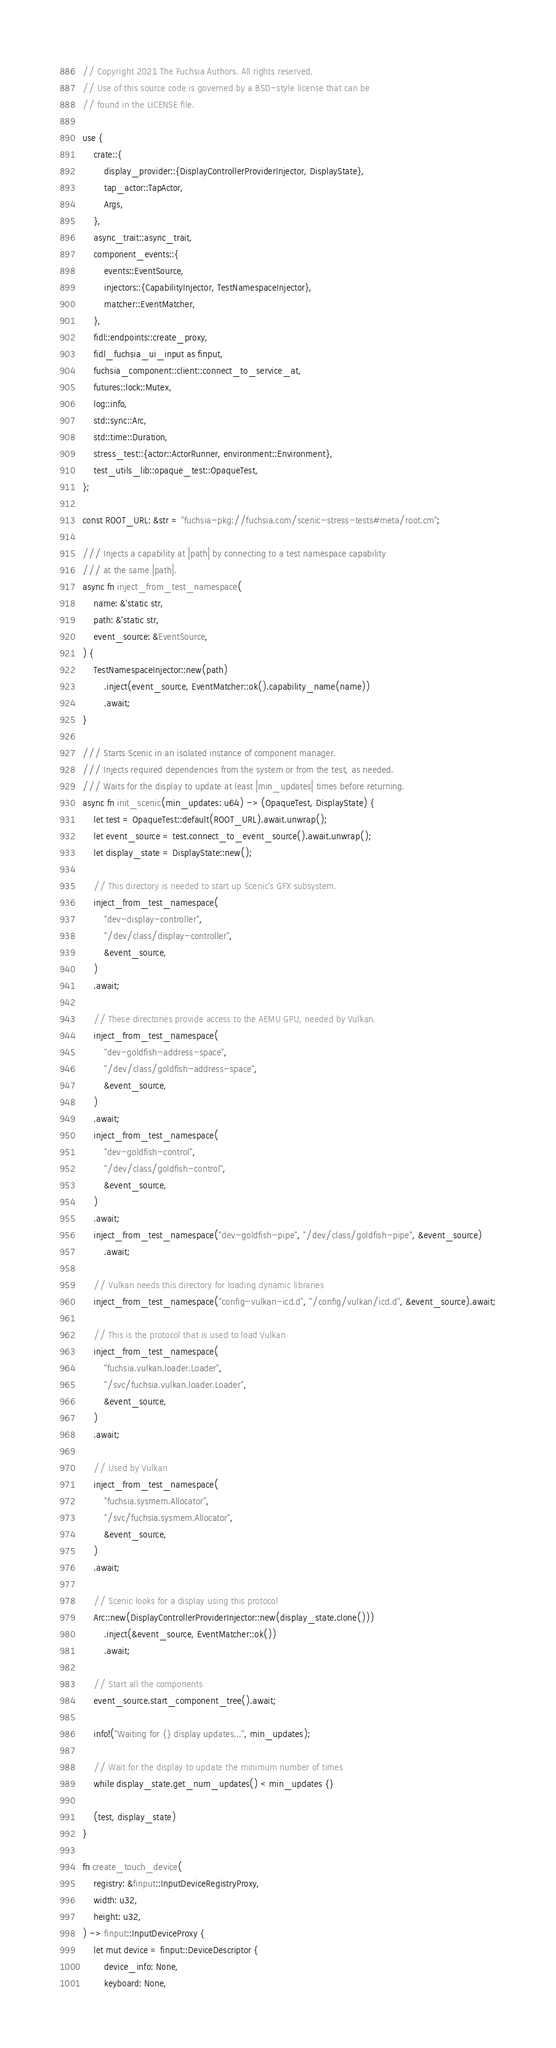Convert code to text. <code><loc_0><loc_0><loc_500><loc_500><_Rust_>// Copyright 2021 The Fuchsia Authors. All rights reserved.
// Use of this source code is governed by a BSD-style license that can be
// found in the LICENSE file.

use {
    crate::{
        display_provider::{DisplayControllerProviderInjector, DisplayState},
        tap_actor::TapActor,
        Args,
    },
    async_trait::async_trait,
    component_events::{
        events::EventSource,
        injectors::{CapabilityInjector, TestNamespaceInjector},
        matcher::EventMatcher,
    },
    fidl::endpoints::create_proxy,
    fidl_fuchsia_ui_input as finput,
    fuchsia_component::client::connect_to_service_at,
    futures::lock::Mutex,
    log::info,
    std::sync::Arc,
    std::time::Duration,
    stress_test::{actor::ActorRunner, environment::Environment},
    test_utils_lib::opaque_test::OpaqueTest,
};

const ROOT_URL: &str = "fuchsia-pkg://fuchsia.com/scenic-stress-tests#meta/root.cm";

/// Injects a capability at |path| by connecting to a test namespace capability
/// at the same |path|.
async fn inject_from_test_namespace(
    name: &'static str,
    path: &'static str,
    event_source: &EventSource,
) {
    TestNamespaceInjector::new(path)
        .inject(event_source, EventMatcher::ok().capability_name(name))
        .await;
}

/// Starts Scenic in an isolated instance of component manager.
/// Injects required dependencies from the system or from the test, as needed.
/// Waits for the display to update at least |min_updates| times before returning.
async fn init_scenic(min_updates: u64) -> (OpaqueTest, DisplayState) {
    let test = OpaqueTest::default(ROOT_URL).await.unwrap();
    let event_source = test.connect_to_event_source().await.unwrap();
    let display_state = DisplayState::new();

    // This directory is needed to start up Scenic's GFX subsystem.
    inject_from_test_namespace(
        "dev-display-controller",
        "/dev/class/display-controller",
        &event_source,
    )
    .await;

    // These directories provide access to the AEMU GPU, needed by Vulkan.
    inject_from_test_namespace(
        "dev-goldfish-address-space",
        "/dev/class/goldfish-address-space",
        &event_source,
    )
    .await;
    inject_from_test_namespace(
        "dev-goldfish-control",
        "/dev/class/goldfish-control",
        &event_source,
    )
    .await;
    inject_from_test_namespace("dev-goldfish-pipe", "/dev/class/goldfish-pipe", &event_source)
        .await;

    // Vulkan needs this directory for loading dynamic libraries
    inject_from_test_namespace("config-vulkan-icd.d", "/config/vulkan/icd.d", &event_source).await;

    // This is the protocol that is used to load Vulkan
    inject_from_test_namespace(
        "fuchsia.vulkan.loader.Loader",
        "/svc/fuchsia.vulkan.loader.Loader",
        &event_source,
    )
    .await;

    // Used by Vulkan
    inject_from_test_namespace(
        "fuchsia.sysmem.Allocator",
        "/svc/fuchsia.sysmem.Allocator",
        &event_source,
    )
    .await;

    // Scenic looks for a display using this protocol
    Arc::new(DisplayControllerProviderInjector::new(display_state.clone()))
        .inject(&event_source, EventMatcher::ok())
        .await;

    // Start all the components
    event_source.start_component_tree().await;

    info!("Waiting for {} display updates...", min_updates);

    // Wait for the display to update the minimum number of times
    while display_state.get_num_updates() < min_updates {}

    (test, display_state)
}

fn create_touch_device(
    registry: &finput::InputDeviceRegistryProxy,
    width: u32,
    height: u32,
) -> finput::InputDeviceProxy {
    let mut device = finput::DeviceDescriptor {
        device_info: None,
        keyboard: None,</code> 